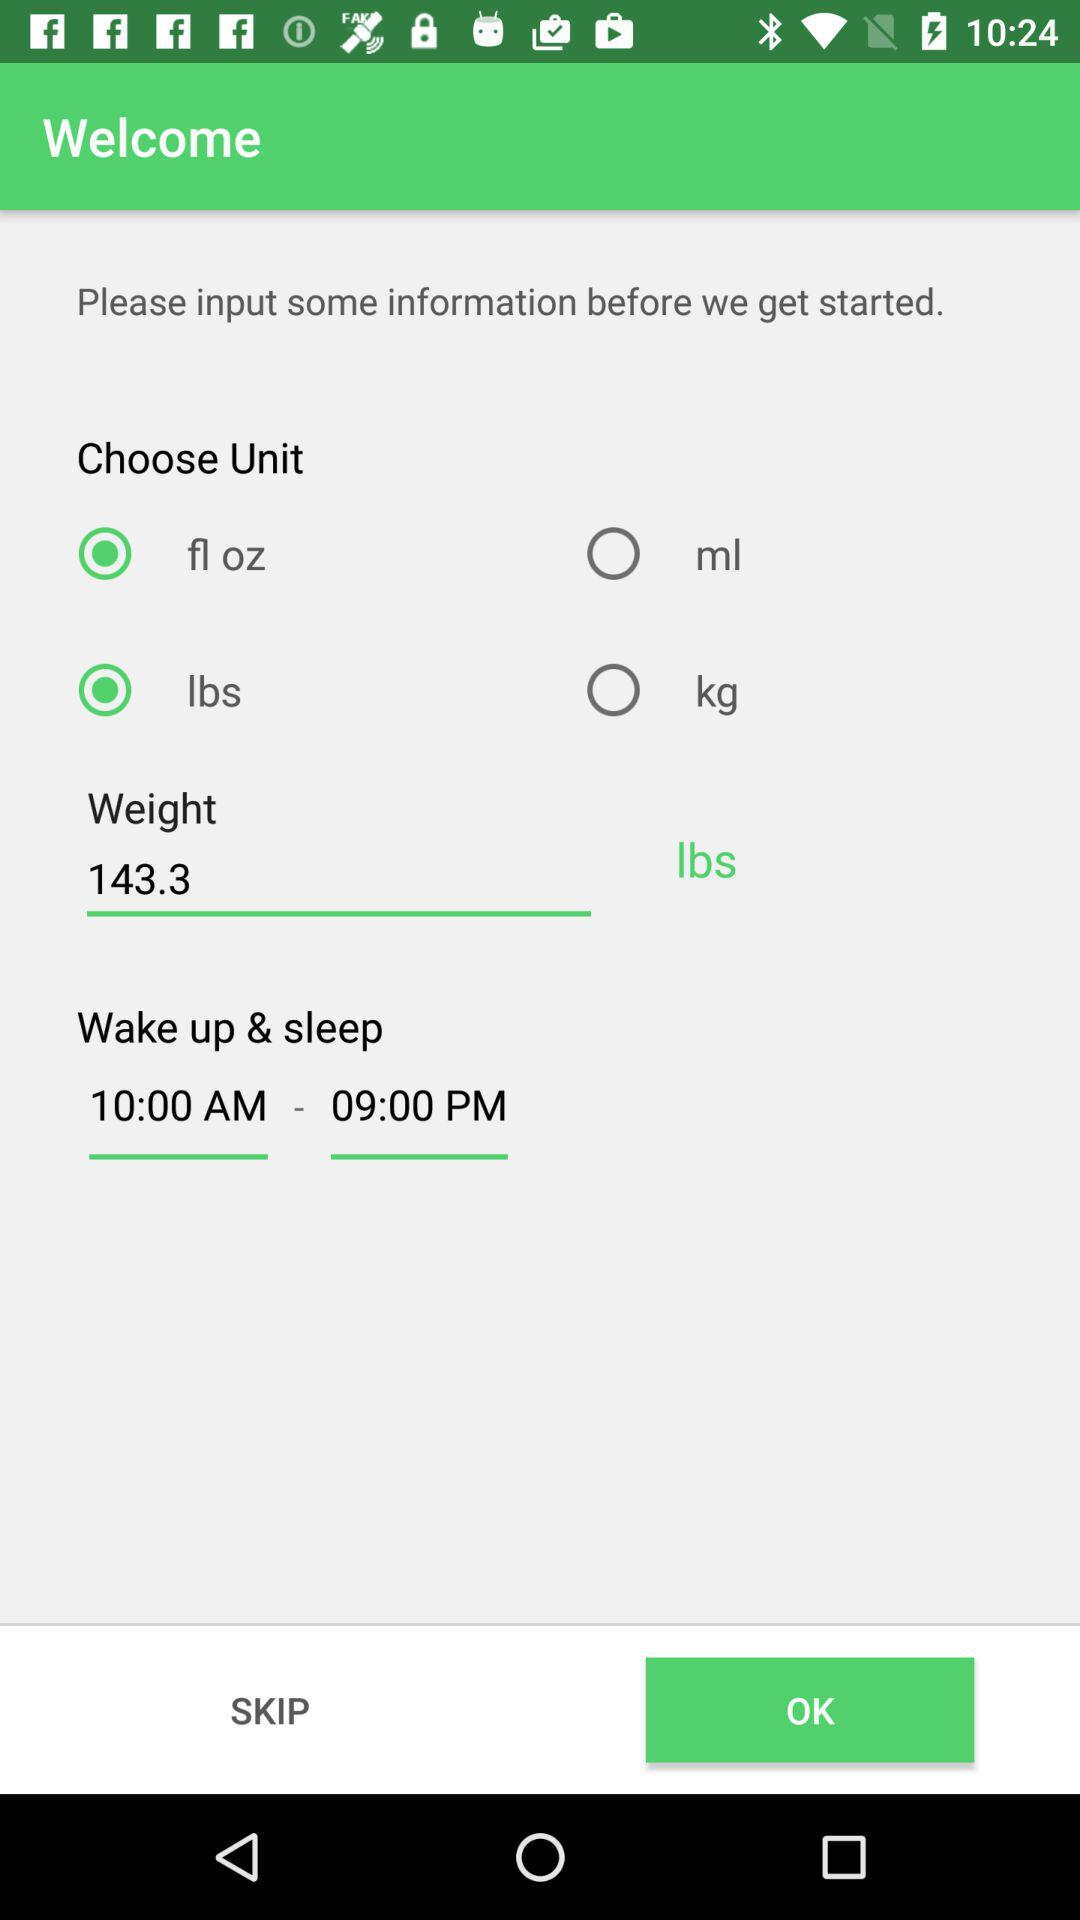What is the selected time for waking up and sleeping? The selected time for waking up is 10 AM and for sleeping is 9 PM. 